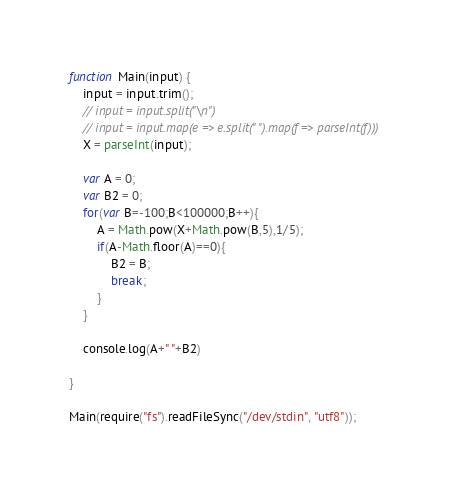Convert code to text. <code><loc_0><loc_0><loc_500><loc_500><_JavaScript_>
function Main(input) {
    input = input.trim();
    // input = input.split("\n")
    // input = input.map(e => e.split(" ").map(f => parseInt(f)))
    X = parseInt(input);

    var A = 0;
    var B2 = 0;
    for(var B=-100;B<100000;B++){
        A = Math.pow(X+Math.pow(B,5),1/5);        
        if(A-Math.floor(A)==0){
            B2 = B;
            break;
        }
    }

    console.log(A+" "+B2)

}

Main(require("fs").readFileSync("/dev/stdin", "utf8"));
</code> 